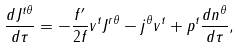<formula> <loc_0><loc_0><loc_500><loc_500>\frac { d J ^ { t \theta } } { d \tau } = - \frac { f ^ { \prime } } { 2 f } v ^ { t } J ^ { r \theta } - j ^ { \theta } v ^ { t } + p ^ { t } \frac { d n ^ { \theta } } { d \tau } ,</formula> 